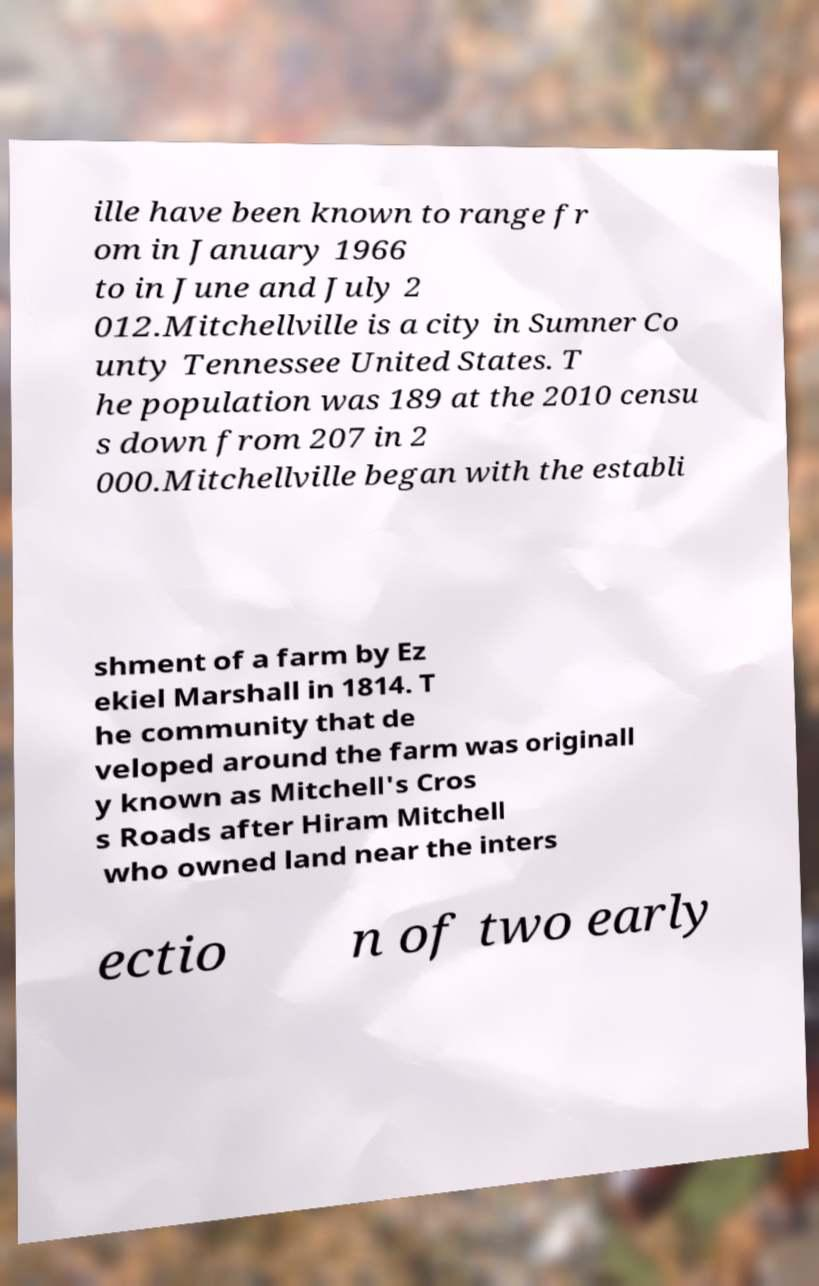What messages or text are displayed in this image? I need them in a readable, typed format. ille have been known to range fr om in January 1966 to in June and July 2 012.Mitchellville is a city in Sumner Co unty Tennessee United States. T he population was 189 at the 2010 censu s down from 207 in 2 000.Mitchellville began with the establi shment of a farm by Ez ekiel Marshall in 1814. T he community that de veloped around the farm was originall y known as Mitchell's Cros s Roads after Hiram Mitchell who owned land near the inters ectio n of two early 